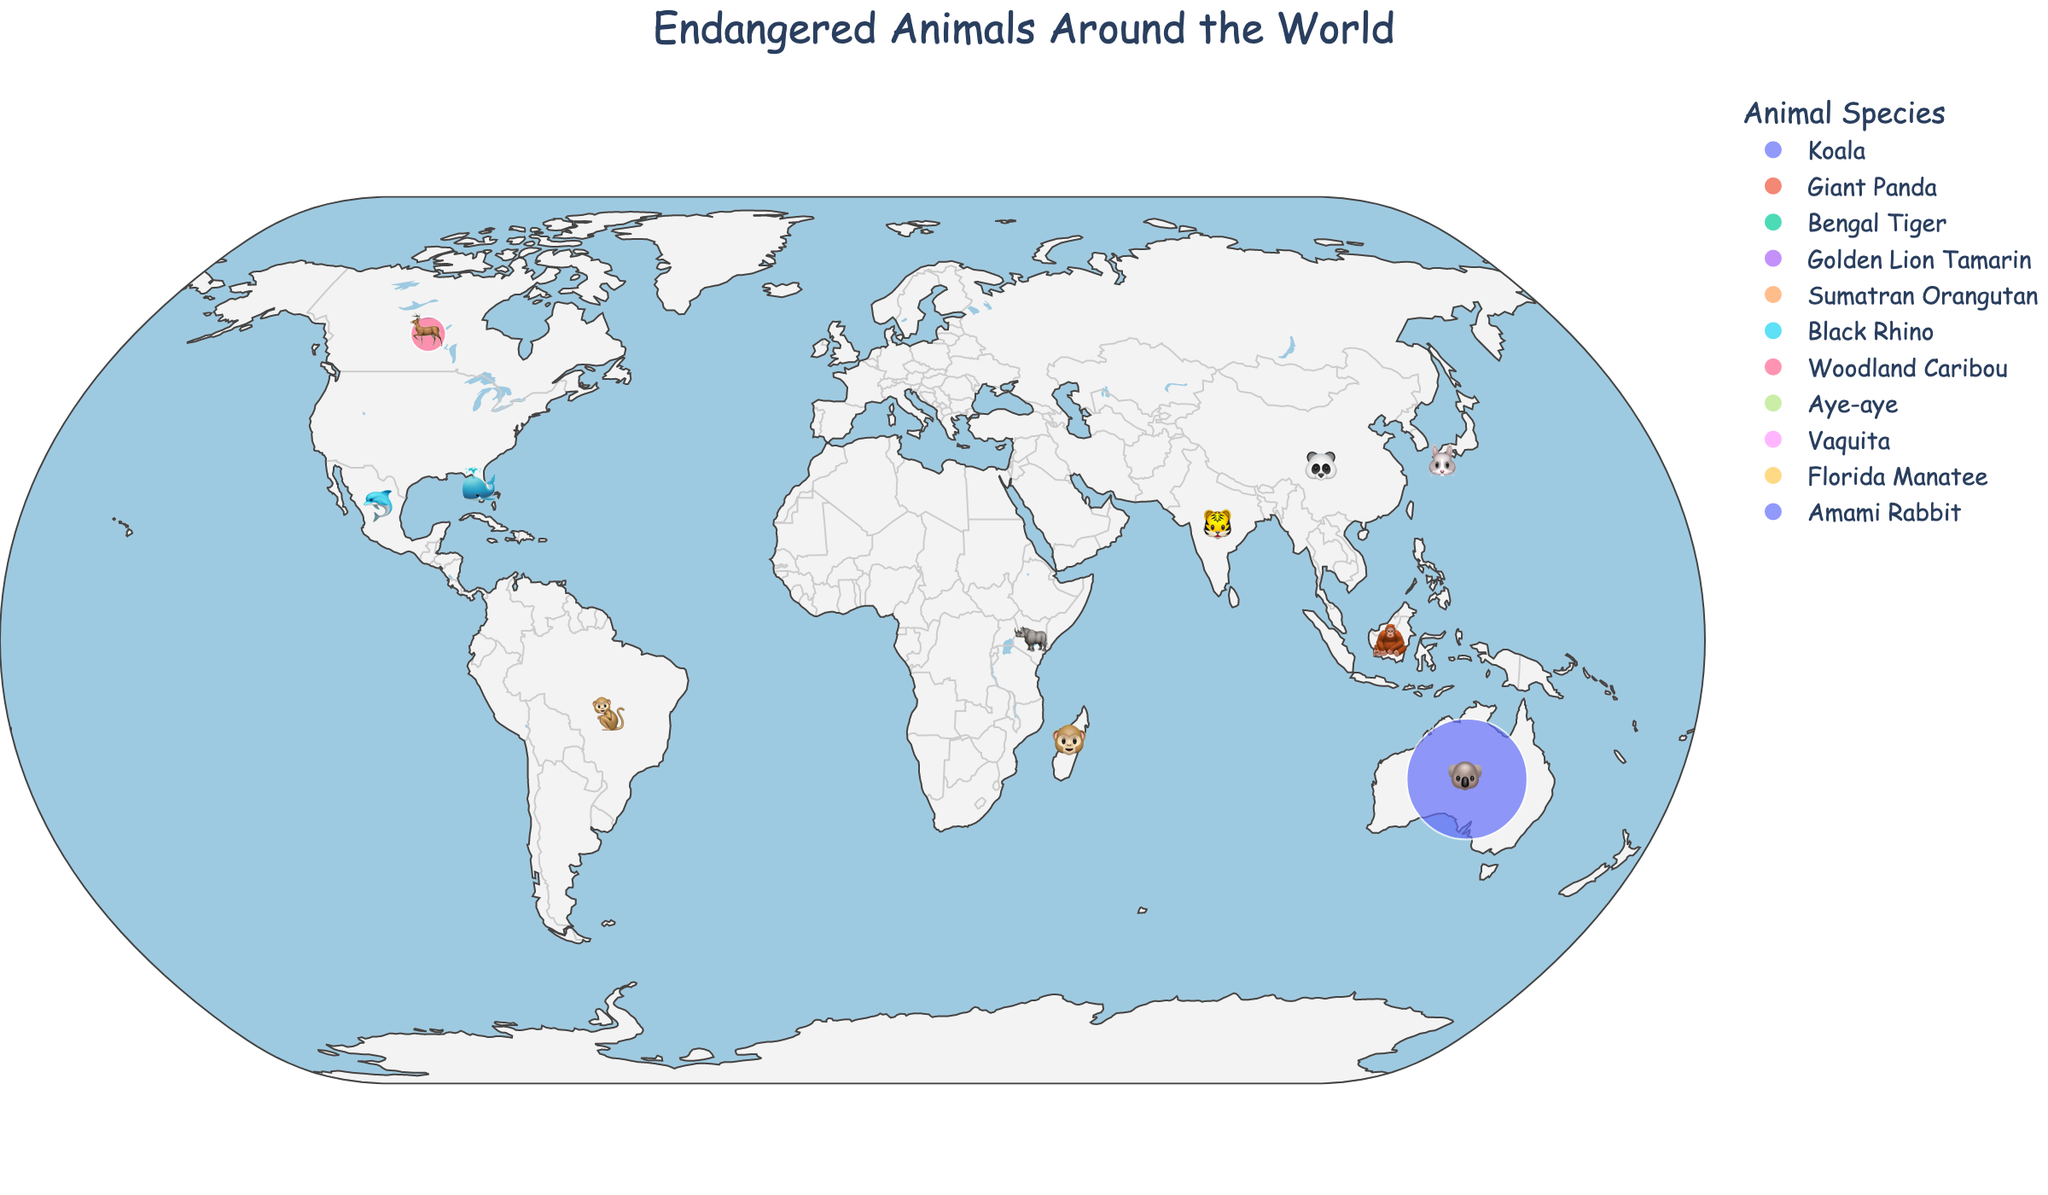What is the title of the figure? The title is displayed at the top center of the figure. It reads 'Endangered Animals Around the World'.
Answer: Endangered Animals Around the World Which animal has the smallest population, and in which country is it located? We need to look for the smallest circle on the map. The smallest population is for the Vaquita, and it is located in Mexico.
Answer: Vaquita, Mexico How many animals have a population of less than 3,000? We need to count the animals with populations less than 3,000: Giant Panda (1,864), Golden Lion Tamarin (2,500), Aye-aye (1,000), Vaquita (10), Amami Rabbit (2,000). There are five such animals.
Answer: 5 Which country has the most endangered animal and what is the population? By looking at the size of the circles, the largest circle represents Australia with its Koala population of 400,000.
Answer: Australia, 400,000 What is the combined population of endangered animals in China, India, and Indonesia? Sum the populations of Giant Panda (1,864) in China, Bengal Tiger (2,967) in India, and Sumatran Orangutan (14,000) in Indonesia. The combined population is 1,864 + 2,967 + 14,000 = 18,831.
Answer: 18,831 Which country is home to the Bengal Tiger, and what is the size of their population? Bengal Tigers are located in India with a population size of 2,967.
Answer: India, 2,967 How many countries have endangered animals with populations exceeding 10,000? Count the countries with populations over 10,000: Woodland Caribou in Canada (34,000), Koala in Australia (400,000), Sumatran Orangutan in Indonesia (14,000). There are three such countries.
Answer: 3 Which animal is represented with the emoji 🐼, and where is it found? The emoji 🐼 represents the Giant Panda, which is found in China.
Answer: Giant Panda, China Comparing the populations of Woodland Caribou and Sumatran Orangutan, which one is larger and by how much? The Woodland Caribou population is 34,000, and the Sumatran Orangutan population is 14,000. The difference is 34,000 - 14,000 = 20,000.
Answer: Woodland Caribou, 20,000 